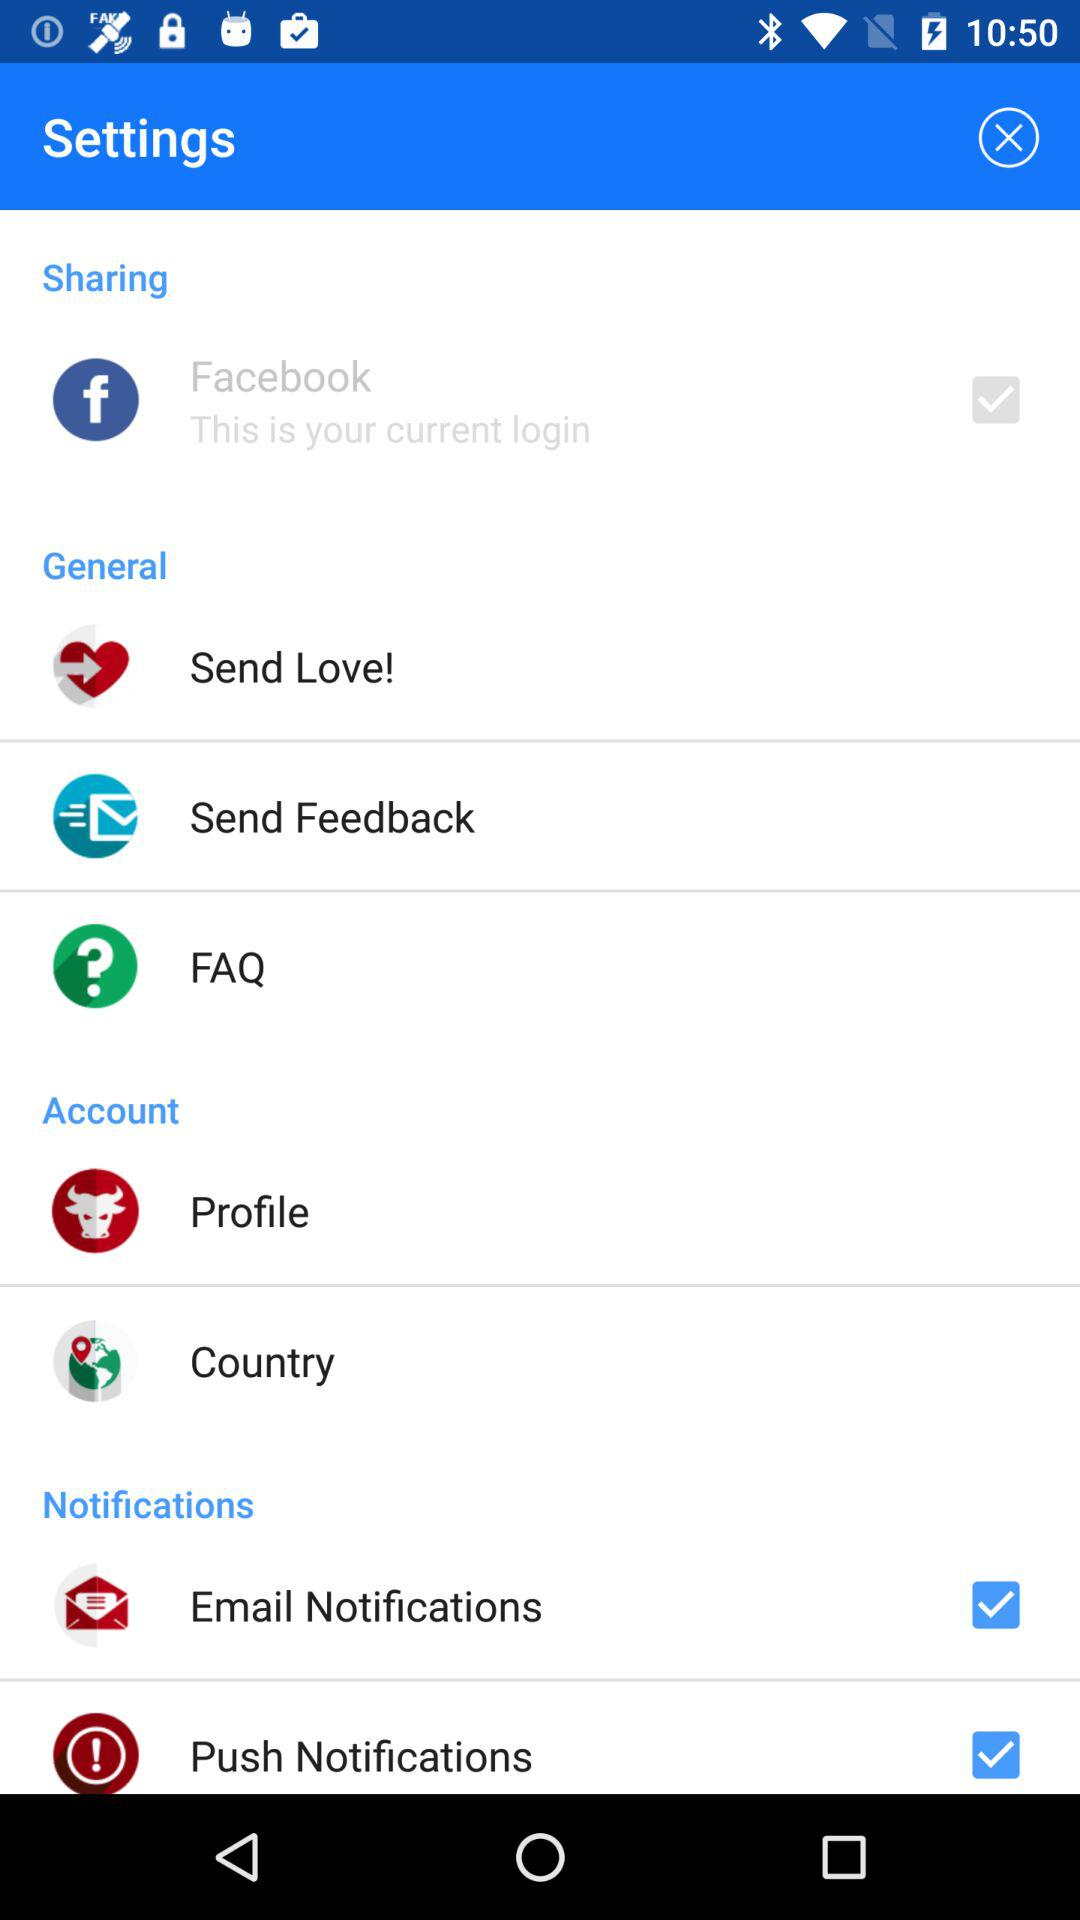How many items in the Notifications section have a checkbox?
Answer the question using a single word or phrase. 2 